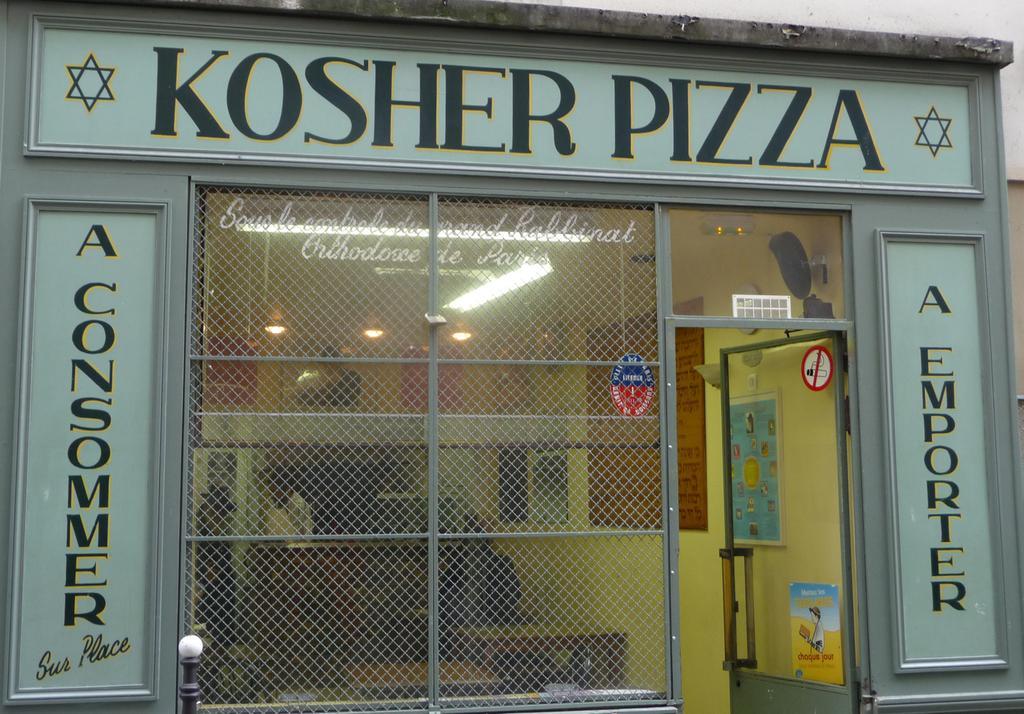Can you describe this image briefly? In this picture I can see a store in front and I can see boards on which there are words written and I can see the glass in front and through the glasses I can see the lights on the ceiling and I can see the wall on which there are few things. I can also see the glass door on which there is a poster and a sticker which is of white and red color. 